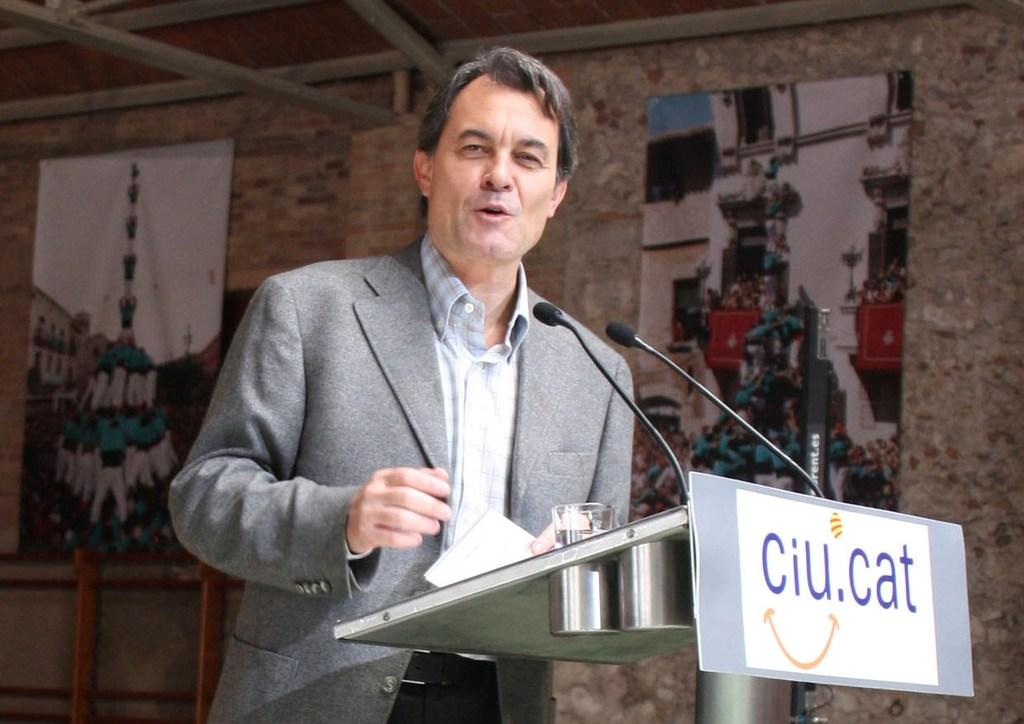What is the man in the image doing near the podium? The man is standing near a podium in the image. What object can be seen in the image that might be used for holding a drink? There is a glass in the image. What surface can be seen in the image that might be used for writing or displaying information? There is a board in the image. What objects can be seen in the image that might be used for amplifying sound? There are microphones (mikes) in the image. What decorative elements can be seen on the wall in the background of the image? There are banners on the wall in the background of the image. What type of apparel is the son wearing in the image? There is no son present in the image, so it is not possible to answer that question. 